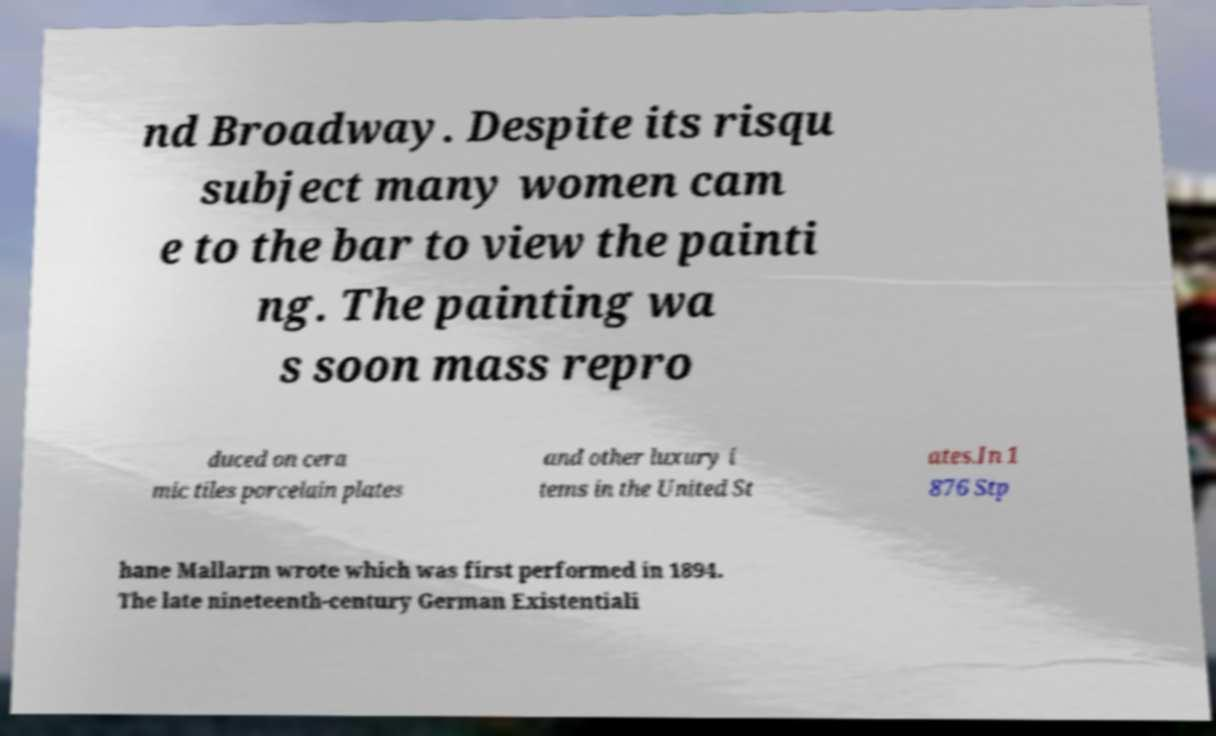There's text embedded in this image that I need extracted. Can you transcribe it verbatim? nd Broadway. Despite its risqu subject many women cam e to the bar to view the painti ng. The painting wa s soon mass repro duced on cera mic tiles porcelain plates and other luxury i tems in the United St ates.In 1 876 Stp hane Mallarm wrote which was first performed in 1894. The late nineteenth-century German Existentiali 